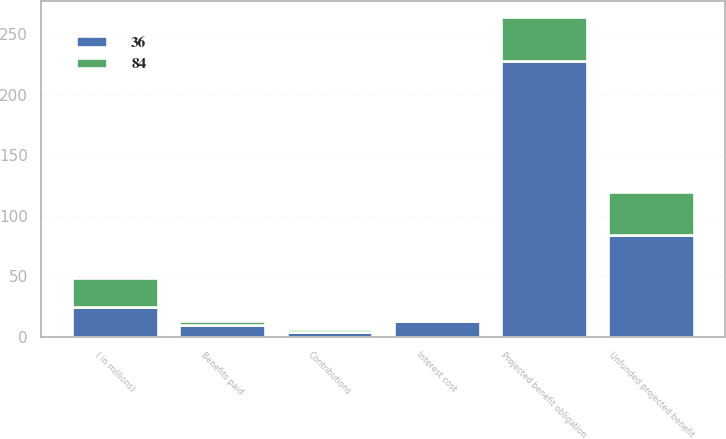Convert chart. <chart><loc_0><loc_0><loc_500><loc_500><stacked_bar_chart><ecel><fcel>( in millions)<fcel>Contributions<fcel>Benefits paid<fcel>Projected benefit obligation<fcel>Interest cost<fcel>Unfunded projected benefit<nl><fcel>36<fcel>24.5<fcel>4<fcel>10<fcel>228<fcel>13<fcel>84<nl><fcel>84<fcel>24.5<fcel>3<fcel>3<fcel>36<fcel>2<fcel>36<nl></chart> 